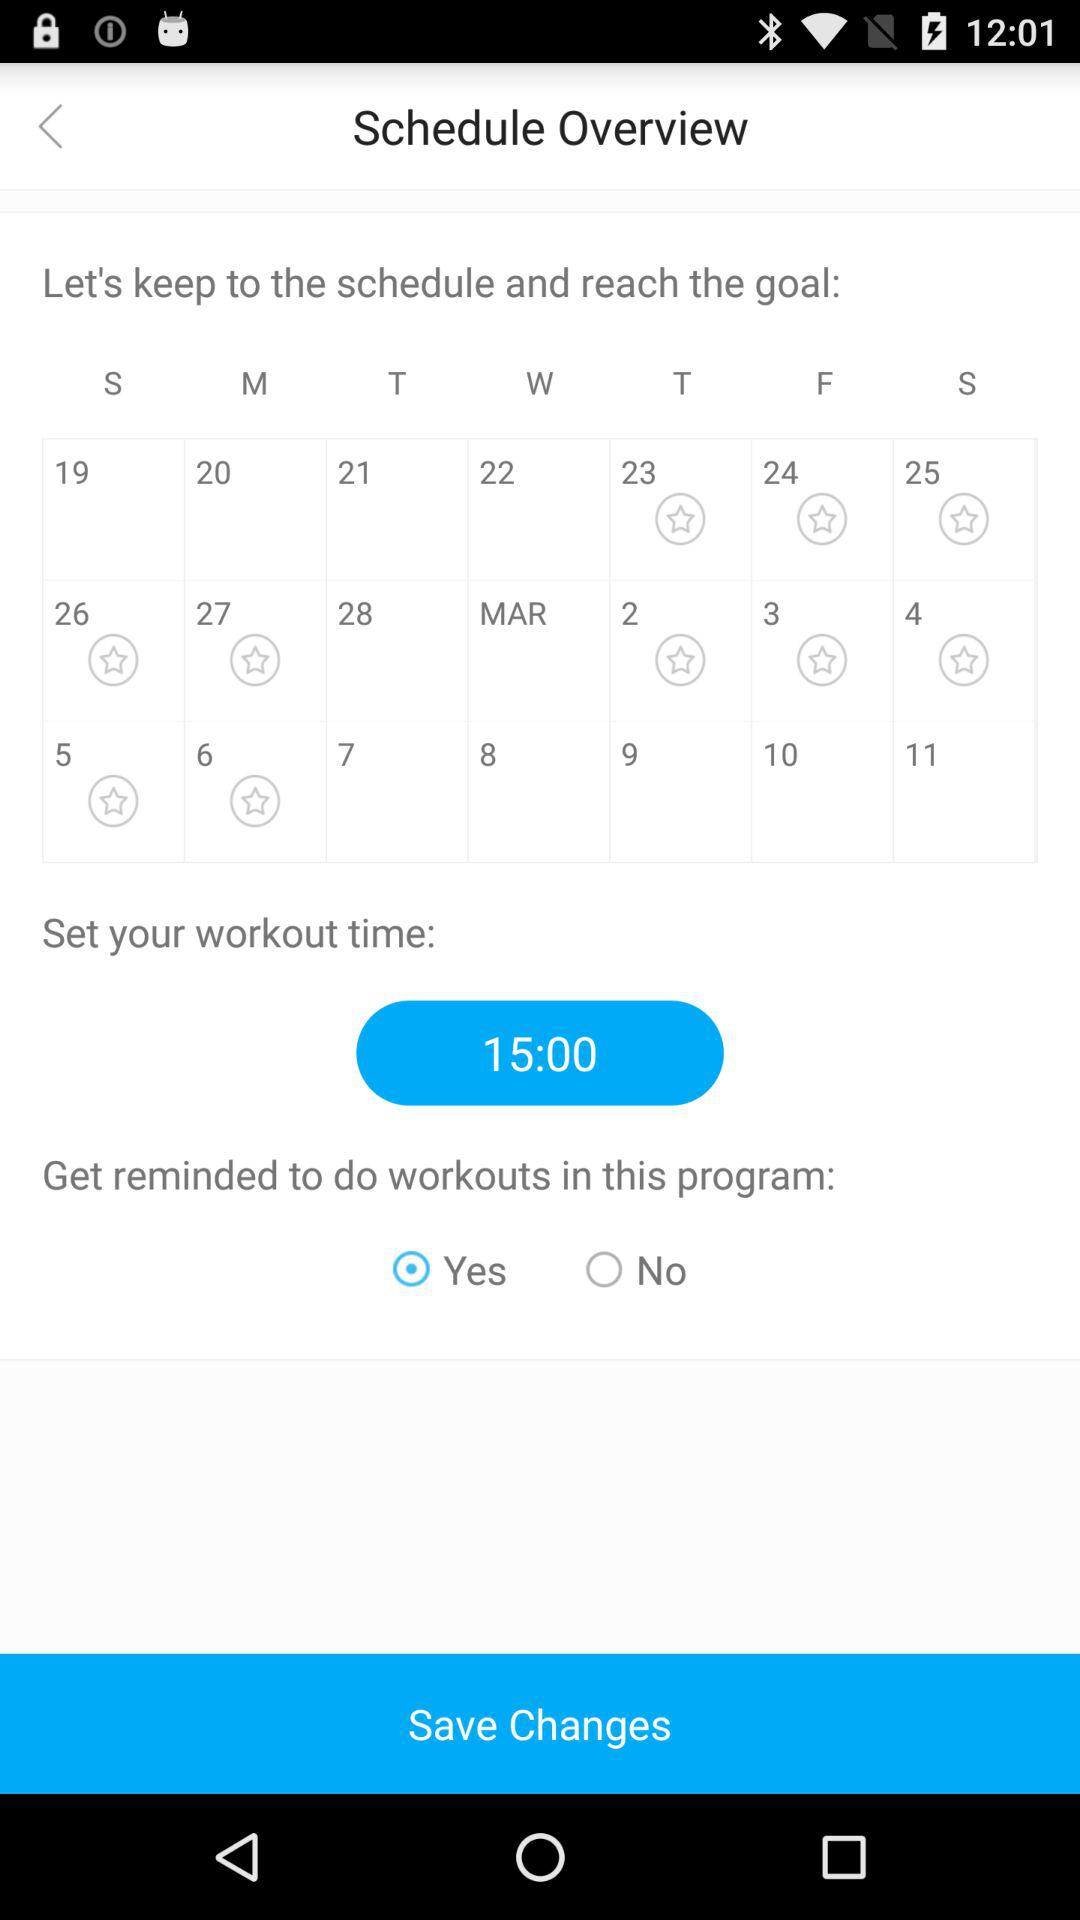Which option is selected? The selected option is "Yes". 